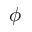<formula> <loc_0><loc_0><loc_500><loc_500>\phi</formula> 